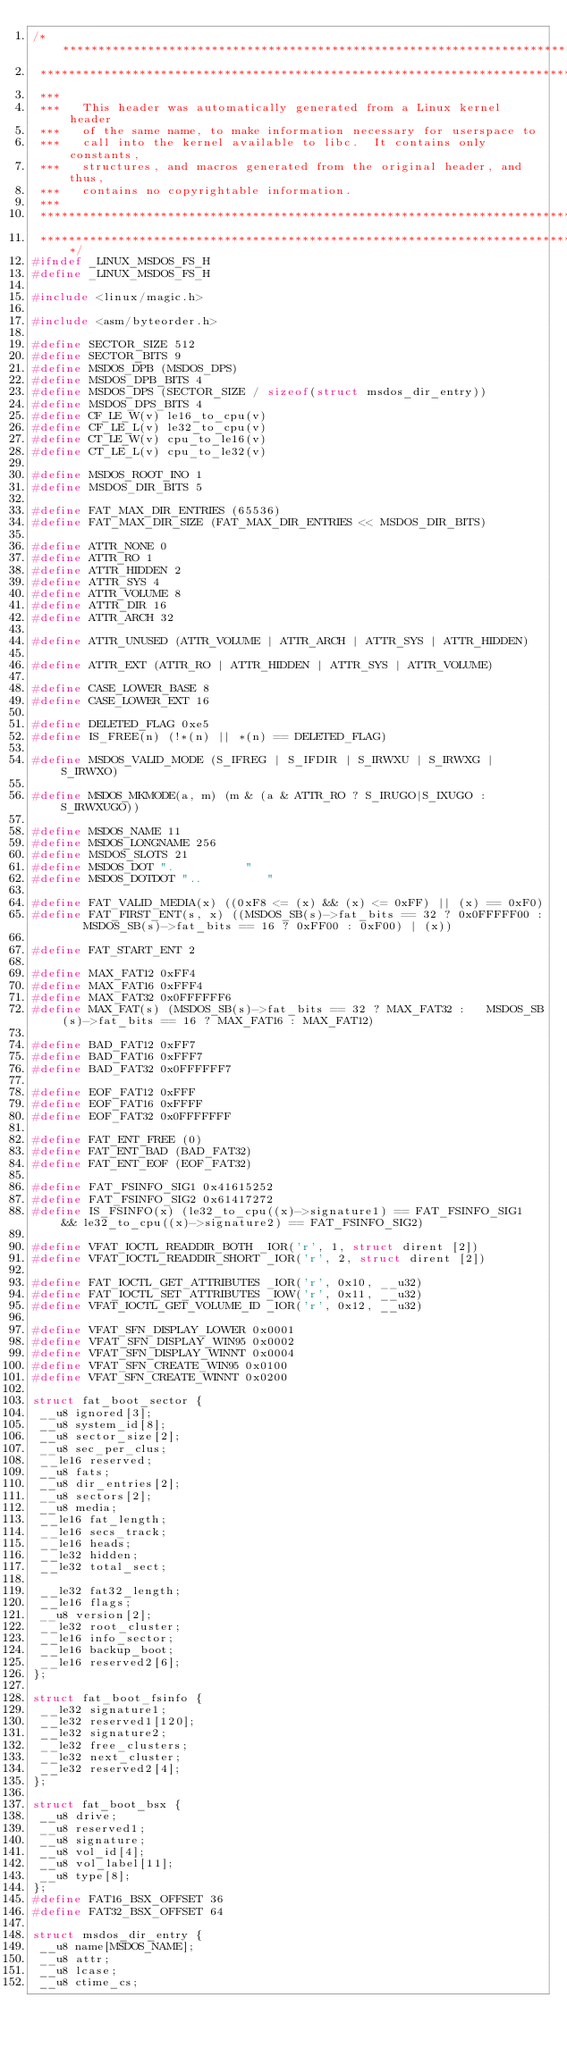Convert code to text. <code><loc_0><loc_0><loc_500><loc_500><_C_>/****************************************************************************
 ****************************************************************************
 ***
 ***   This header was automatically generated from a Linux kernel header
 ***   of the same name, to make information necessary for userspace to
 ***   call into the kernel available to libc.  It contains only constants,
 ***   structures, and macros generated from the original header, and thus,
 ***   contains no copyrightable information.
 ***
 ****************************************************************************
 ****************************************************************************/
#ifndef _LINUX_MSDOS_FS_H
#define _LINUX_MSDOS_FS_H

#include <linux/magic.h>

#include <asm/byteorder.h>

#define SECTOR_SIZE 512  
#define SECTOR_BITS 9  
#define MSDOS_DPB (MSDOS_DPS)  
#define MSDOS_DPB_BITS 4  
#define MSDOS_DPS (SECTOR_SIZE / sizeof(struct msdos_dir_entry))
#define MSDOS_DPS_BITS 4  
#define CF_LE_W(v) le16_to_cpu(v)
#define CF_LE_L(v) le32_to_cpu(v)
#define CT_LE_W(v) cpu_to_le16(v)
#define CT_LE_L(v) cpu_to_le32(v)

#define MSDOS_ROOT_INO 1  
#define MSDOS_DIR_BITS 5  

#define FAT_MAX_DIR_ENTRIES (65536)
#define FAT_MAX_DIR_SIZE (FAT_MAX_DIR_ENTRIES << MSDOS_DIR_BITS)

#define ATTR_NONE 0  
#define ATTR_RO 1  
#define ATTR_HIDDEN 2  
#define ATTR_SYS 4  
#define ATTR_VOLUME 8  
#define ATTR_DIR 16  
#define ATTR_ARCH 32  

#define ATTR_UNUSED (ATTR_VOLUME | ATTR_ARCH | ATTR_SYS | ATTR_HIDDEN)

#define ATTR_EXT (ATTR_RO | ATTR_HIDDEN | ATTR_SYS | ATTR_VOLUME)

#define CASE_LOWER_BASE 8  
#define CASE_LOWER_EXT 16  

#define DELETED_FLAG 0xe5  
#define IS_FREE(n) (!*(n) || *(n) == DELETED_FLAG)

#define MSDOS_VALID_MODE (S_IFREG | S_IFDIR | S_IRWXU | S_IRWXG | S_IRWXO)

#define MSDOS_MKMODE(a, m) (m & (a & ATTR_RO ? S_IRUGO|S_IXUGO : S_IRWXUGO))

#define MSDOS_NAME 11  
#define MSDOS_LONGNAME 256  
#define MSDOS_SLOTS 21  
#define MSDOS_DOT ".          "  
#define MSDOS_DOTDOT "..         "  

#define FAT_VALID_MEDIA(x) ((0xF8 <= (x) && (x) <= 0xFF) || (x) == 0xF0)
#define FAT_FIRST_ENT(s, x) ((MSDOS_SB(s)->fat_bits == 32 ? 0x0FFFFF00 :   MSDOS_SB(s)->fat_bits == 16 ? 0xFF00 : 0xF00) | (x))

#define FAT_START_ENT 2

#define MAX_FAT12 0xFF4
#define MAX_FAT16 0xFFF4
#define MAX_FAT32 0x0FFFFFF6
#define MAX_FAT(s) (MSDOS_SB(s)->fat_bits == 32 ? MAX_FAT32 :   MSDOS_SB(s)->fat_bits == 16 ? MAX_FAT16 : MAX_FAT12)

#define BAD_FAT12 0xFF7
#define BAD_FAT16 0xFFF7
#define BAD_FAT32 0x0FFFFFF7

#define EOF_FAT12 0xFFF
#define EOF_FAT16 0xFFFF
#define EOF_FAT32 0x0FFFFFFF

#define FAT_ENT_FREE (0)
#define FAT_ENT_BAD (BAD_FAT32)
#define FAT_ENT_EOF (EOF_FAT32)

#define FAT_FSINFO_SIG1 0x41615252
#define FAT_FSINFO_SIG2 0x61417272
#define IS_FSINFO(x) (le32_to_cpu((x)->signature1) == FAT_FSINFO_SIG1   && le32_to_cpu((x)->signature2) == FAT_FSINFO_SIG2)

#define VFAT_IOCTL_READDIR_BOTH _IOR('r', 1, struct dirent [2])
#define VFAT_IOCTL_READDIR_SHORT _IOR('r', 2, struct dirent [2])

#define FAT_IOCTL_GET_ATTRIBUTES _IOR('r', 0x10, __u32)
#define FAT_IOCTL_SET_ATTRIBUTES _IOW('r', 0x11, __u32)
#define VFAT_IOCTL_GET_VOLUME_ID _IOR('r', 0x12, __u32)

#define VFAT_SFN_DISPLAY_LOWER 0x0001  
#define VFAT_SFN_DISPLAY_WIN95 0x0002  
#define VFAT_SFN_DISPLAY_WINNT 0x0004  
#define VFAT_SFN_CREATE_WIN95 0x0100  
#define VFAT_SFN_CREATE_WINNT 0x0200  

struct fat_boot_sector {
 __u8 ignored[3];
 __u8 system_id[8];
 __u8 sector_size[2];
 __u8 sec_per_clus;
 __le16 reserved;
 __u8 fats;
 __u8 dir_entries[2];
 __u8 sectors[2];
 __u8 media;
 __le16 fat_length;
 __le16 secs_track;
 __le16 heads;
 __le32 hidden;
 __le32 total_sect;

 __le32 fat32_length;
 __le16 flags;
 __u8 version[2];
 __le32 root_cluster;
 __le16 info_sector;
 __le16 backup_boot;
 __le16 reserved2[6];
};

struct fat_boot_fsinfo {
 __le32 signature1;
 __le32 reserved1[120];
 __le32 signature2;
 __le32 free_clusters;
 __le32 next_cluster;
 __le32 reserved2[4];
};

struct fat_boot_bsx {
 __u8 drive;
 __u8 reserved1;
 __u8 signature;
 __u8 vol_id[4];
 __u8 vol_label[11];
 __u8 type[8];
};
#define FAT16_BSX_OFFSET 36  
#define FAT32_BSX_OFFSET 64  

struct msdos_dir_entry {
 __u8 name[MSDOS_NAME];
 __u8 attr;
 __u8 lcase;
 __u8 ctime_cs;</code> 